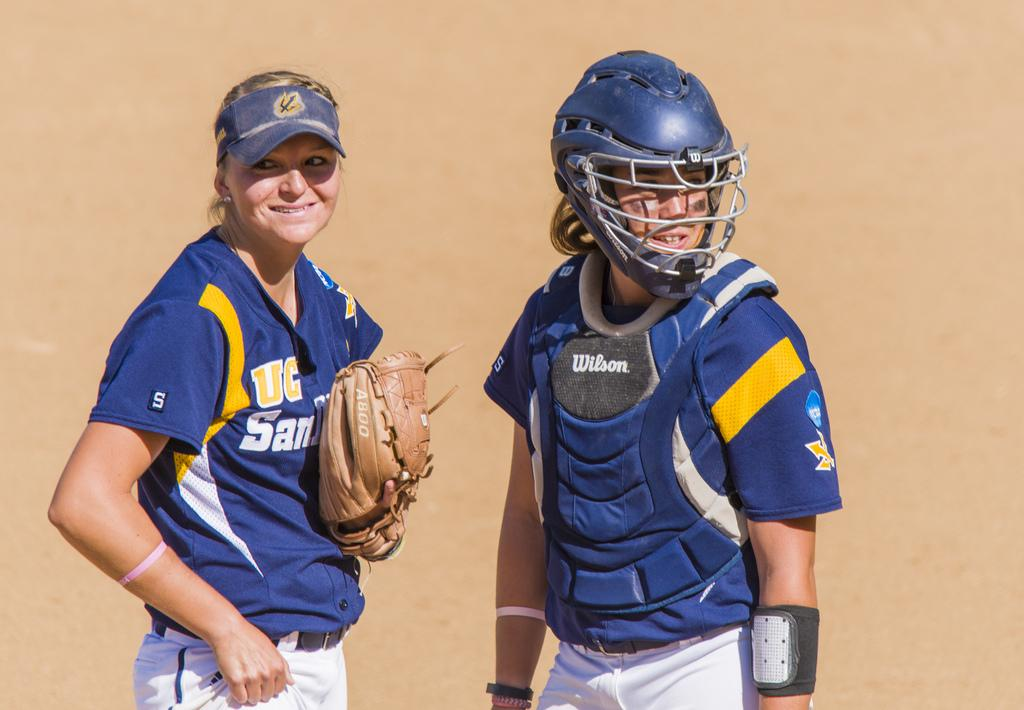<image>
Render a clear and concise summary of the photo. Two female baseball players, a pitcher with her mitt, and a catcher wearing Wilson brand protective gear in front. 